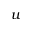Convert formula to latex. <formula><loc_0><loc_0><loc_500><loc_500>u</formula> 